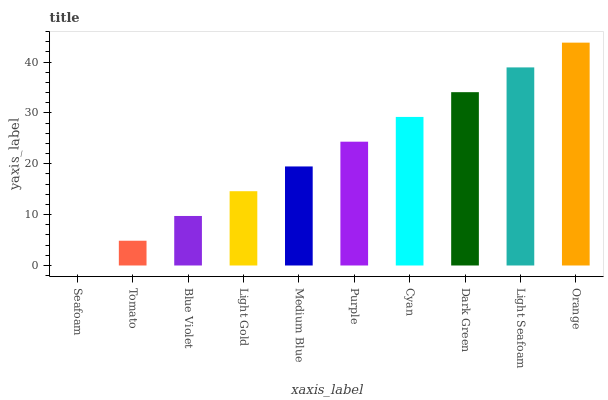Is Seafoam the minimum?
Answer yes or no. Yes. Is Orange the maximum?
Answer yes or no. Yes. Is Tomato the minimum?
Answer yes or no. No. Is Tomato the maximum?
Answer yes or no. No. Is Tomato greater than Seafoam?
Answer yes or no. Yes. Is Seafoam less than Tomato?
Answer yes or no. Yes. Is Seafoam greater than Tomato?
Answer yes or no. No. Is Tomato less than Seafoam?
Answer yes or no. No. Is Purple the high median?
Answer yes or no. Yes. Is Medium Blue the low median?
Answer yes or no. Yes. Is Dark Green the high median?
Answer yes or no. No. Is Cyan the low median?
Answer yes or no. No. 